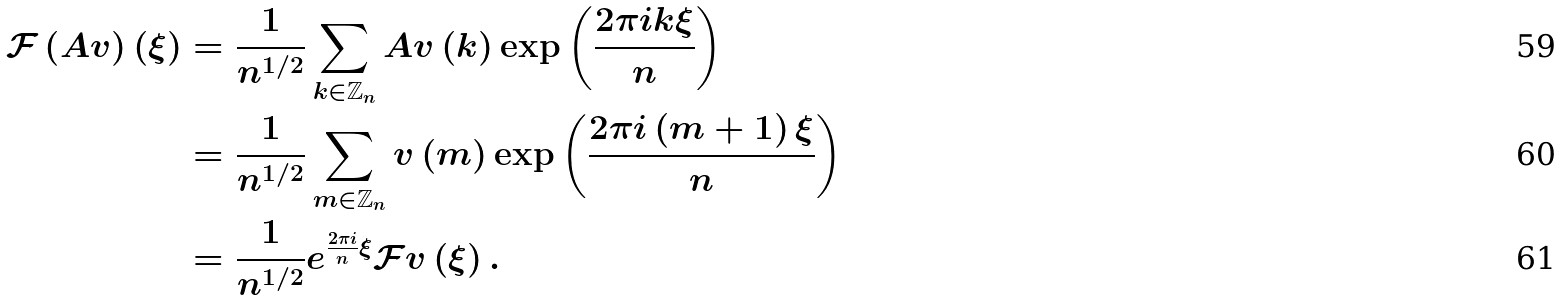<formula> <loc_0><loc_0><loc_500><loc_500>\mathcal { F } \left ( A v \right ) \left ( \xi \right ) & = \frac { 1 } { n ^ { 1 / 2 } } \sum _ { k \in \mathbb { Z } _ { n } } A v \left ( k \right ) \exp \left ( \frac { 2 \pi i k \xi } { n } \right ) \\ & = \frac { 1 } { n ^ { 1 / 2 } } \sum _ { m \in \mathbb { Z } _ { n } } v \left ( m \right ) \exp \left ( \frac { 2 \pi i \left ( m + 1 \right ) \xi } { n } \right ) \\ & = \frac { 1 } { n ^ { 1 / 2 } } e ^ { \frac { 2 \pi i } { n } \xi } \mathcal { F } v \left ( \xi \right ) .</formula> 